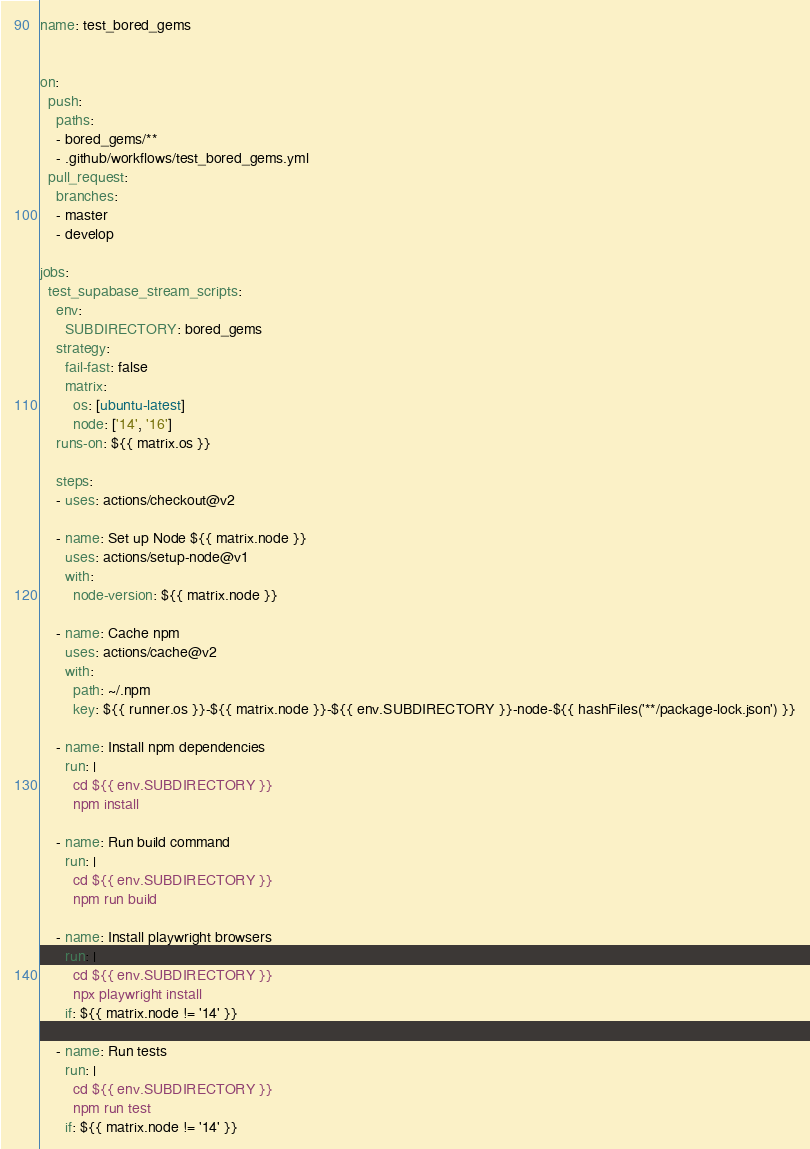<code> <loc_0><loc_0><loc_500><loc_500><_YAML_>name: test_bored_gems


on:
  push:
    paths:
    - bored_gems/**
    - .github/workflows/test_bored_gems.yml
  pull_request:
    branches:
    - master
    - develop

jobs:
  test_supabase_stream_scripts:
    env:
      SUBDIRECTORY: bored_gems
    strategy:
      fail-fast: false
      matrix:
        os: [ubuntu-latest]
        node: ['14', '16']
    runs-on: ${{ matrix.os }}

    steps:
    - uses: actions/checkout@v2

    - name: Set up Node ${{ matrix.node }}
      uses: actions/setup-node@v1
      with:
        node-version: ${{ matrix.node }}

    - name: Cache npm
      uses: actions/cache@v2
      with:
        path: ~/.npm
        key: ${{ runner.os }}-${{ matrix.node }}-${{ env.SUBDIRECTORY }}-node-${{ hashFiles('**/package-lock.json') }}

    - name: Install npm dependencies
      run: |
        cd ${{ env.SUBDIRECTORY }}
        npm install

    - name: Run build command
      run: |
        cd ${{ env.SUBDIRECTORY }}
        npm run build

    - name: Install playwright browsers
      run: |
        cd ${{ env.SUBDIRECTORY }}
        npx playwright install
      if: ${{ matrix.node != '14' }}

    - name: Run tests
      run: |
        cd ${{ env.SUBDIRECTORY }}
        npm run test
      if: ${{ matrix.node != '14' }}
</code> 